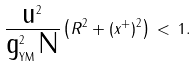Convert formula to latex. <formula><loc_0><loc_0><loc_500><loc_500>\frac { \text {u} ^ { 2 } } { \text {g} ^ { 2 } _ { \text {YM} } \, \text {N} } \left ( R ^ { 2 } + ( x ^ { + } ) ^ { 2 } \right ) \, < \, 1 .</formula> 